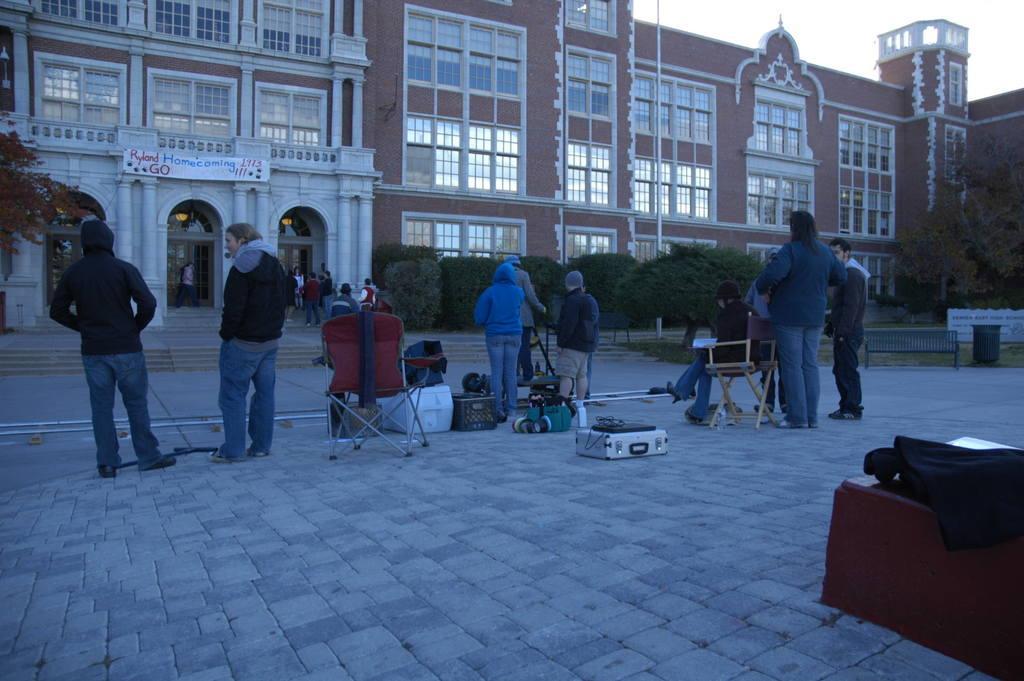How would you summarize this image in a sentence or two? In the picture we can see some people are standing on the path and with some things are placed on it and far away from them we can see some plants and behind it we can see buildings with windows and glasses to it and near to the building we can also see grass surface on it we can see a bench and a tree and behind the house we can see a sky. 